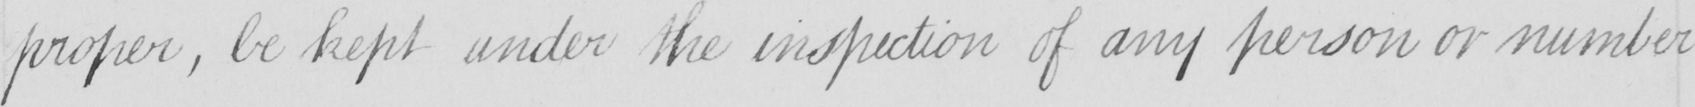Please provide the text content of this handwritten line. proper , be kept under the inspection of any person or number 